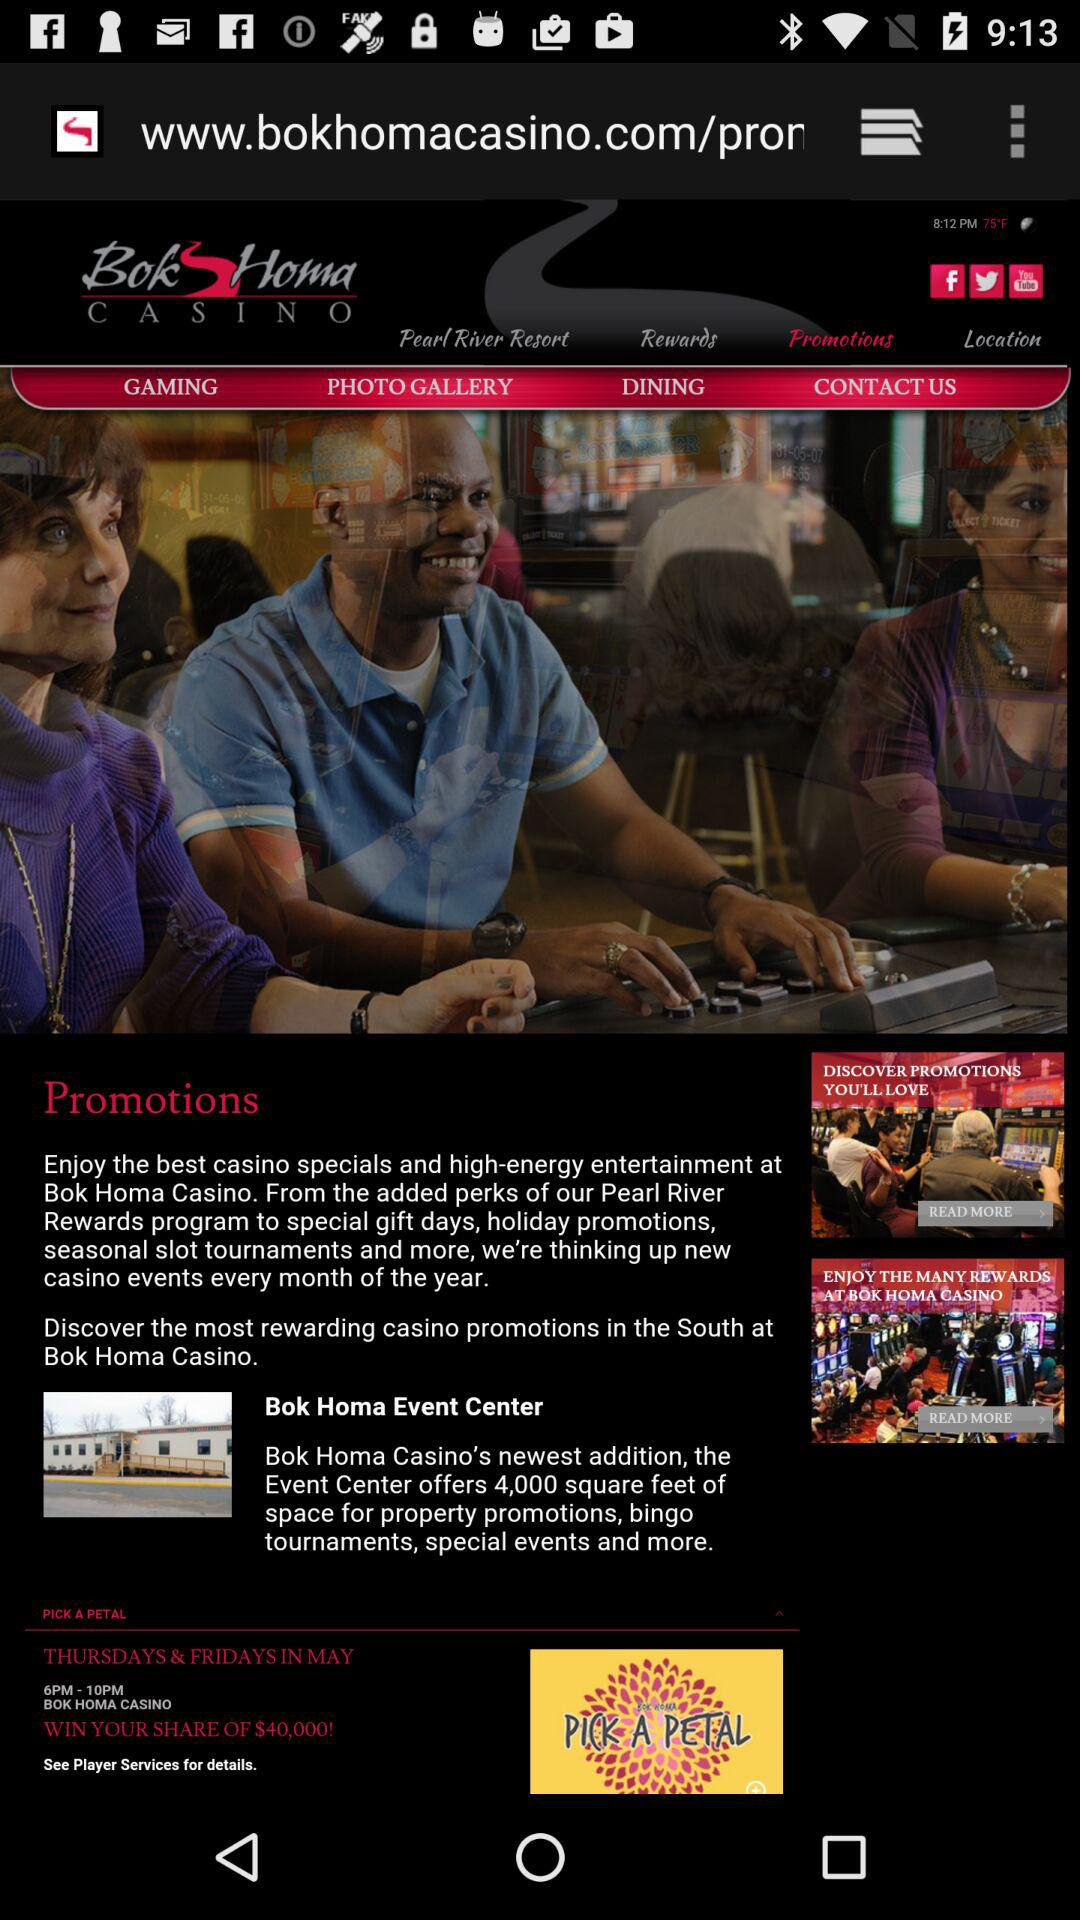Which tab is selected? The selected tab is "Promotions". 